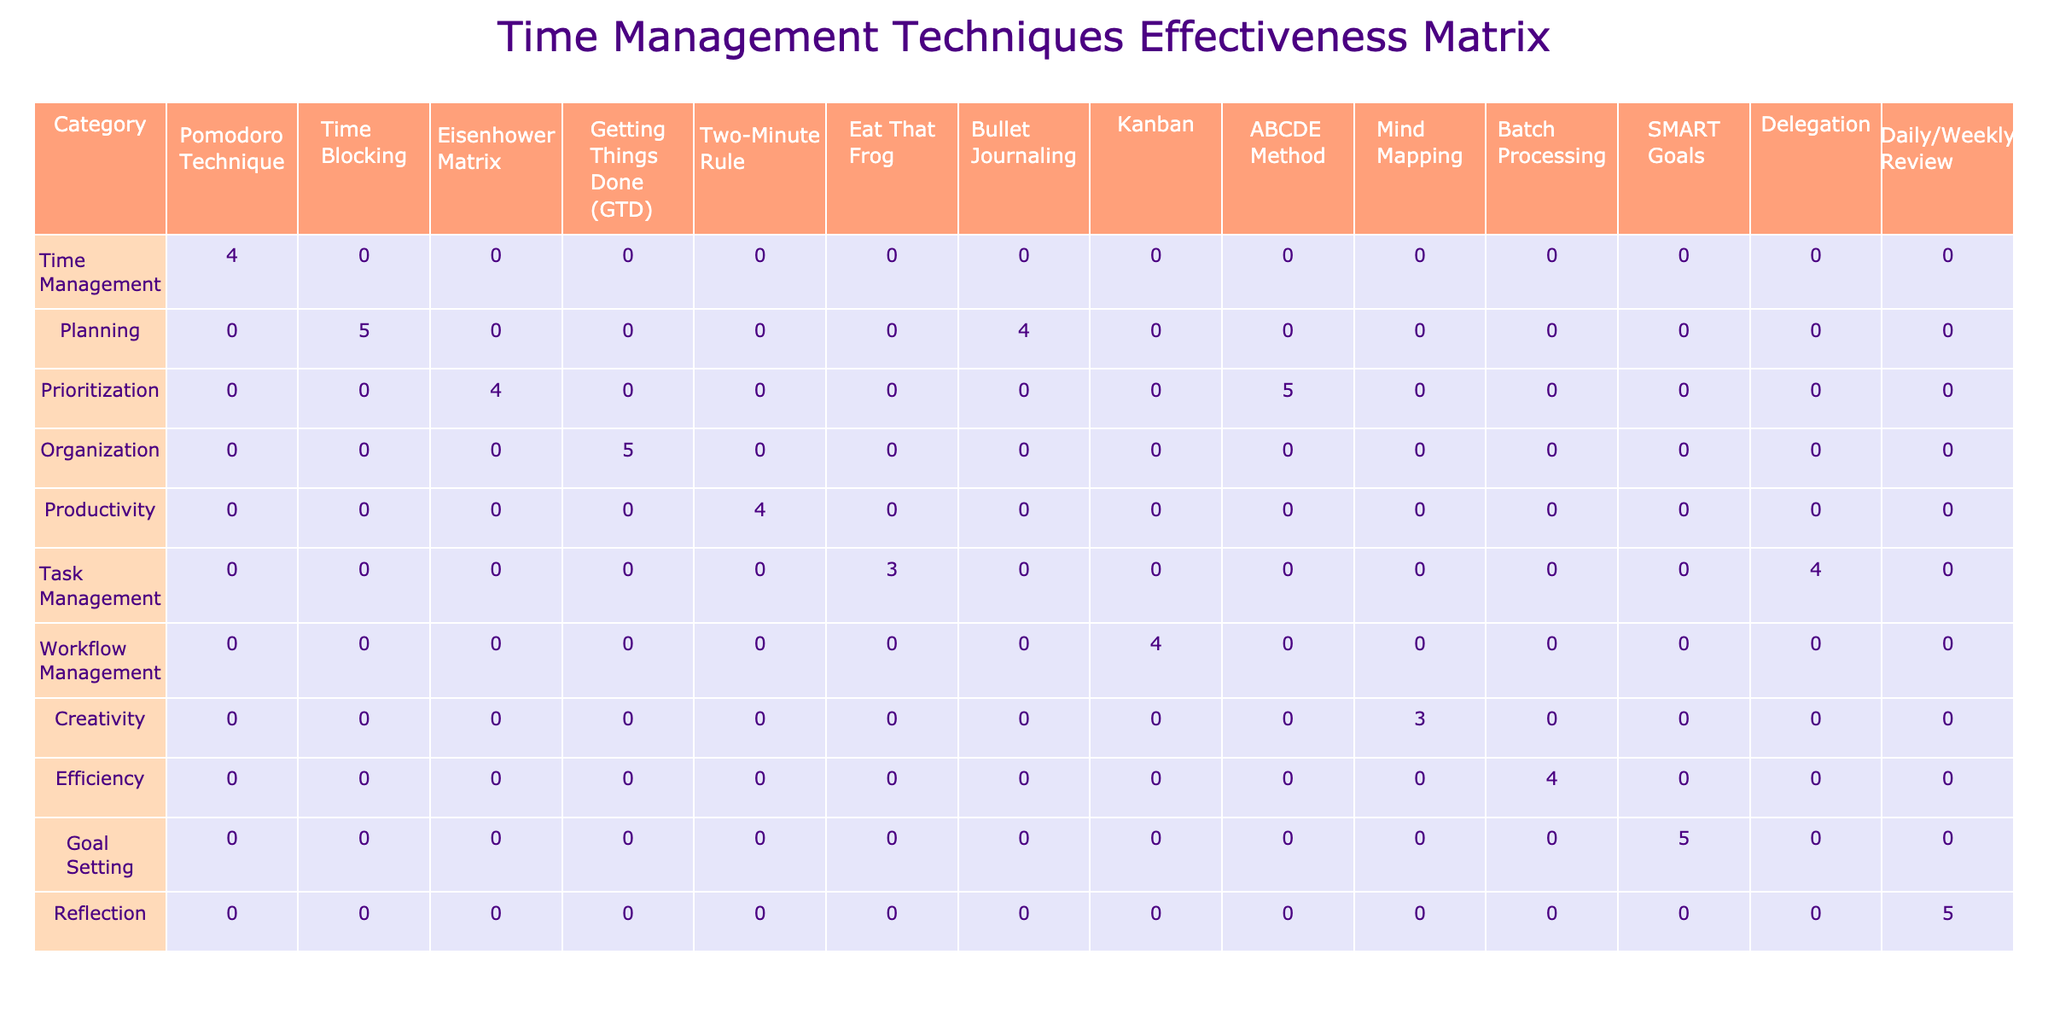What is the effectiveness rating of the Time Blocking technique? The Time Blocking technique is located under the 'Planning' category. Referring to the effectiveness rating in the table for this technique, it shows a rating of 5.
Answer: 5 Which technique has the highest effectiveness rating? Looking through the ratings of all techniques, both Time Blocking, Getting Things Done (GTD), ABCDE Method, SMART Goals, and Daily/Weekly Review have the highest effectiveness rating of 5.
Answer: Time Blocking, Getting Things Done (GTD), ABCDE Method, SMART Goals, Daily/Weekly Review What is the average effectiveness rating for techniques in the organization category? The only technique in the Organization category is Getting Things Done (GTD), which has an effectiveness rating of 5. Since there's only one data point, the average is simply 5.
Answer: 5 Is the Delegation technique more effective than the Eat That Frog technique? The effectiveness rating for Delegation is 4, while the rating for Eat That Frog is 3. Since 4 is greater than 3, Delegation is indeed more effective than Eat That Frog.
Answer: Yes How many techniques have an effectiveness rating of 4 or higher? The techniques with ratings of 4 or higher are: Pomodoro Technique, Time Blocking, Eisenhower Matrix, Getting Things Done (GTD), Two-Minute Rule, Bullet Journaling, Kanban, Batch Processing, Delegation, and Daily/Weekly Review. Counting these gives a total of 10 techniques.
Answer: 10 What is the difference in effectiveness ratings between the highest and lowest rated techniques? The highest rating is 5 (for Time Blocking, Getting Things Done (GTD), ABCDE Method, SMART Goals, Daily/Weekly Review) and the lowest is 3 (for Eat That Frog and Mind Mapping). The difference is 5 - 3 = 2.
Answer: 2 In which category does the Two-Minute Rule technique belong? The Two-Minute Rule technique is categorized under Productivity, as indicated in the table’s category column.
Answer: Productivity Which techniques fall under the Planning category? The techniques listed under the Planning category are Time Blocking and Bullet Journaling. These two can be found by checking the respective category in the table.
Answer: Time Blocking, Bullet Journaling What is the effectiveness rating for the Batch Processing technique and how does it compare to Mind Mapping? The effectiveness rating for Batch Processing is 4 while Mind Mapping has a rating of 3. Comparing these two, Batch Processing is more effective than Mind Mapping since 4 is greater than 3.
Answer: Batch Processing is more effective 